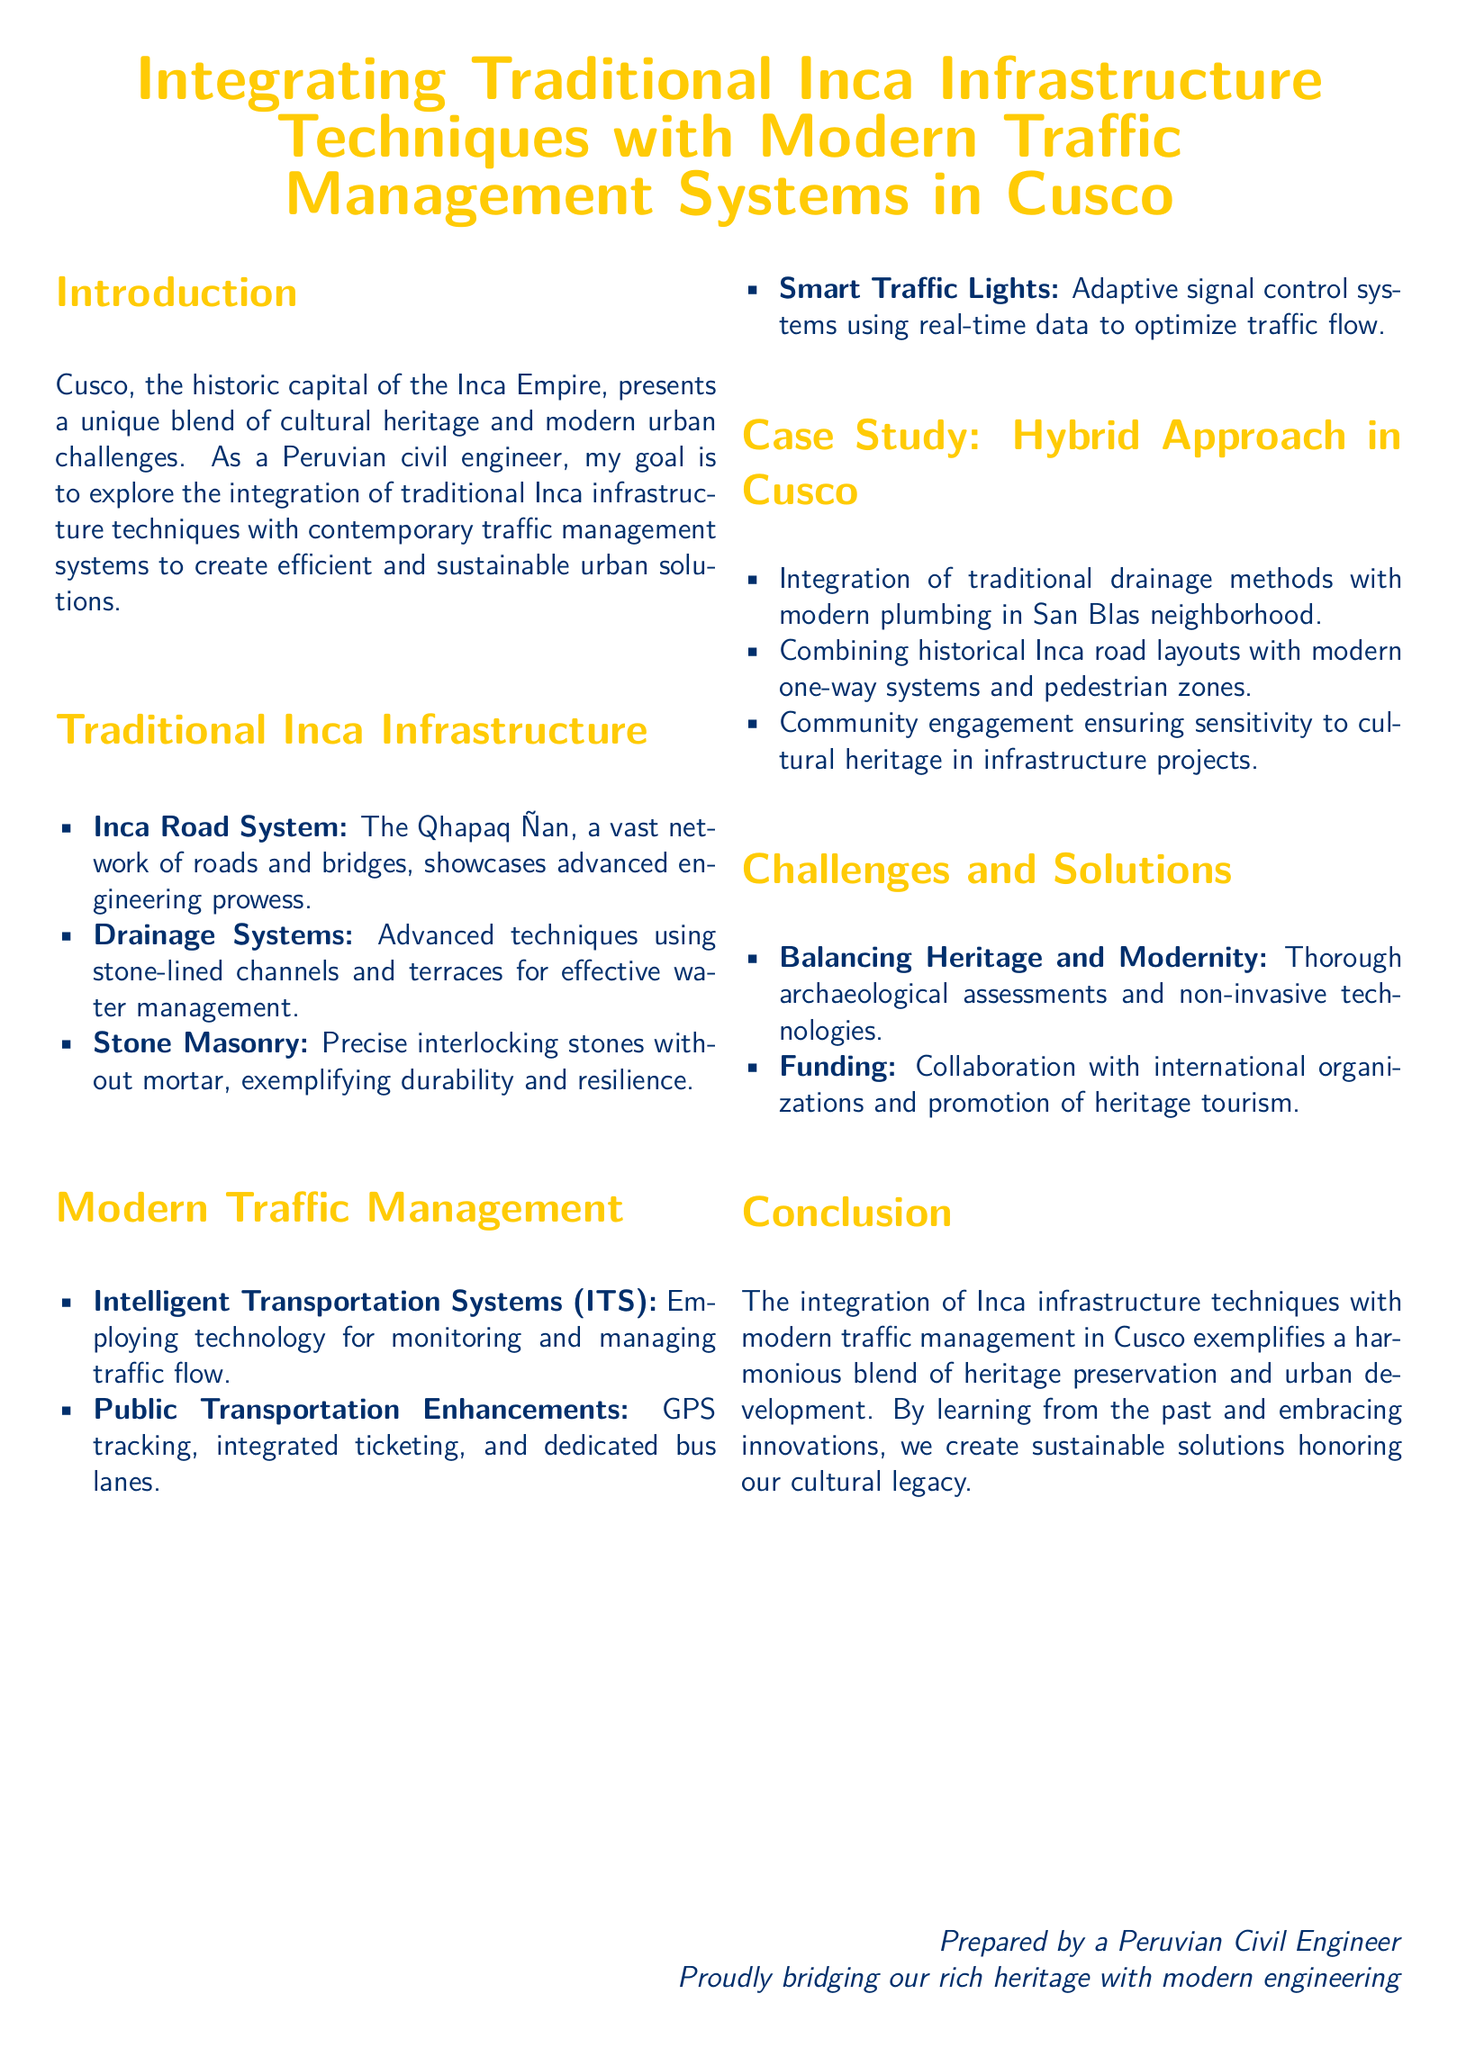What is the historic capital of the Inca Empire? The document states that Cusco is the historic capital of the Inca Empire.
Answer: Cusco What is the name of the Inca road system? The document refers to the vast network of roads and bridges as the Qhapaq Ñan.
Answer: Qhapaq Ñan What advanced drainage technique is mentioned? It mentions stone-lined channels and terraces for effective water management as the drainage technique.
Answer: Stone-lined channels What technology is used in Intelligent Transportation Systems? The document discusses employing technology for monitoring and managing traffic flow under ITS.
Answer: Monitoring and managing traffic flow What is one enhancement for public transportation? The document lists GPS tracking as an enhancement for public transportation.
Answer: GPS tracking What is a challenge addressed in the document? The document identifies "Balancing Heritage and Modernity" as a challenge.
Answer: Balancing Heritage and Modernity What kind of community aspect is crucial in infrastructure projects? The importance of community engagement is highlighted to ensure sensitivity to cultural heritage.
Answer: Community engagement What does the conclusion emphasize about the integration efforts? The conclusion emphasizes that the integration exemplifies a harmonious blend of heritage preservation and urban development.
Answer: Heritage preservation and urban development What type of collaboration is mentioned for funding? The document mentions collaboration with international organizations for funding.
Answer: Collaboration with international organizations 